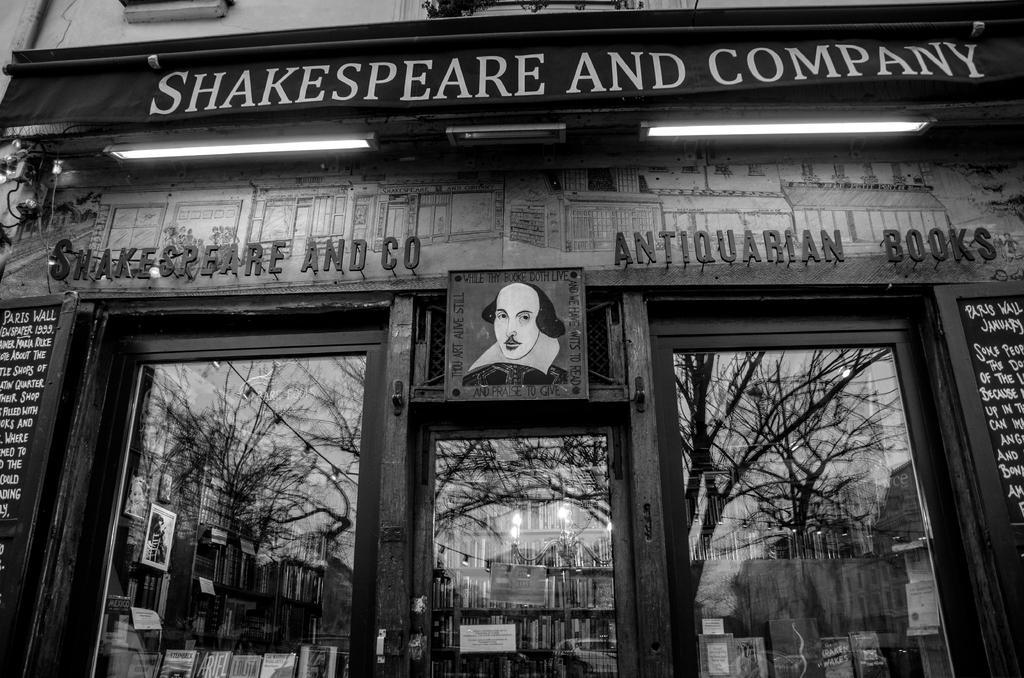Describe this image in one or two sentences. In this Picture we can see the glass door of the shop. Above there is a naming board with "Shakespeare and company" in written. 